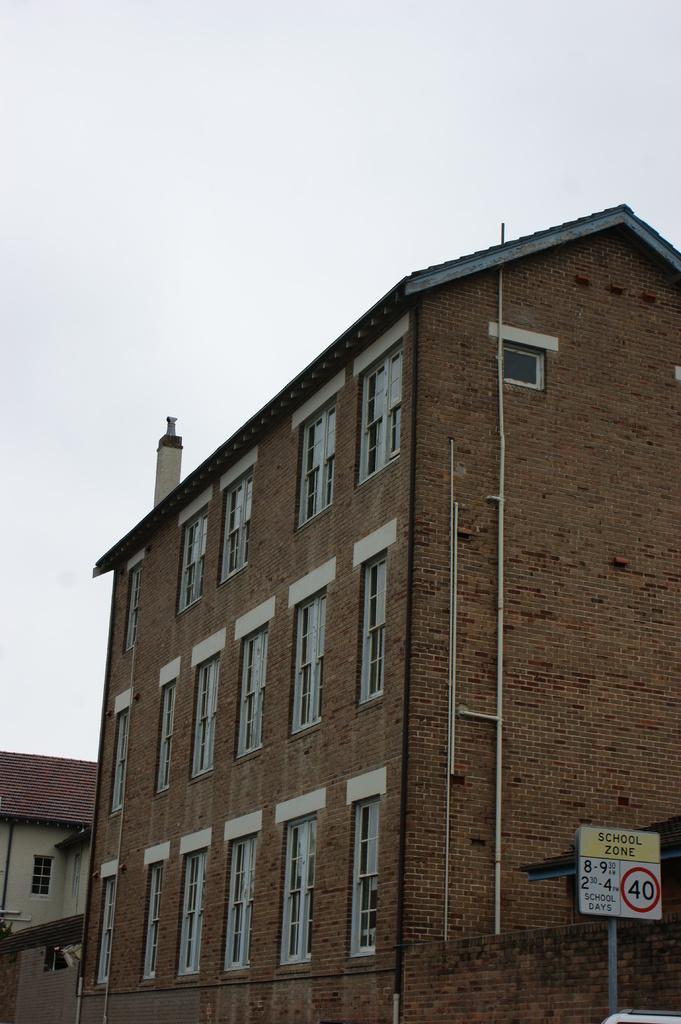Describe this image in one or two sentences. In this image there are buildings. In the background there is the sky. 